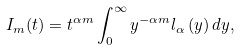Convert formula to latex. <formula><loc_0><loc_0><loc_500><loc_500>I _ { m } ( t ) = t ^ { \alpha m } \int _ { 0 } ^ { \infty } y ^ { - \alpha m } l _ { \alpha } \left ( y \right ) d y ,</formula> 